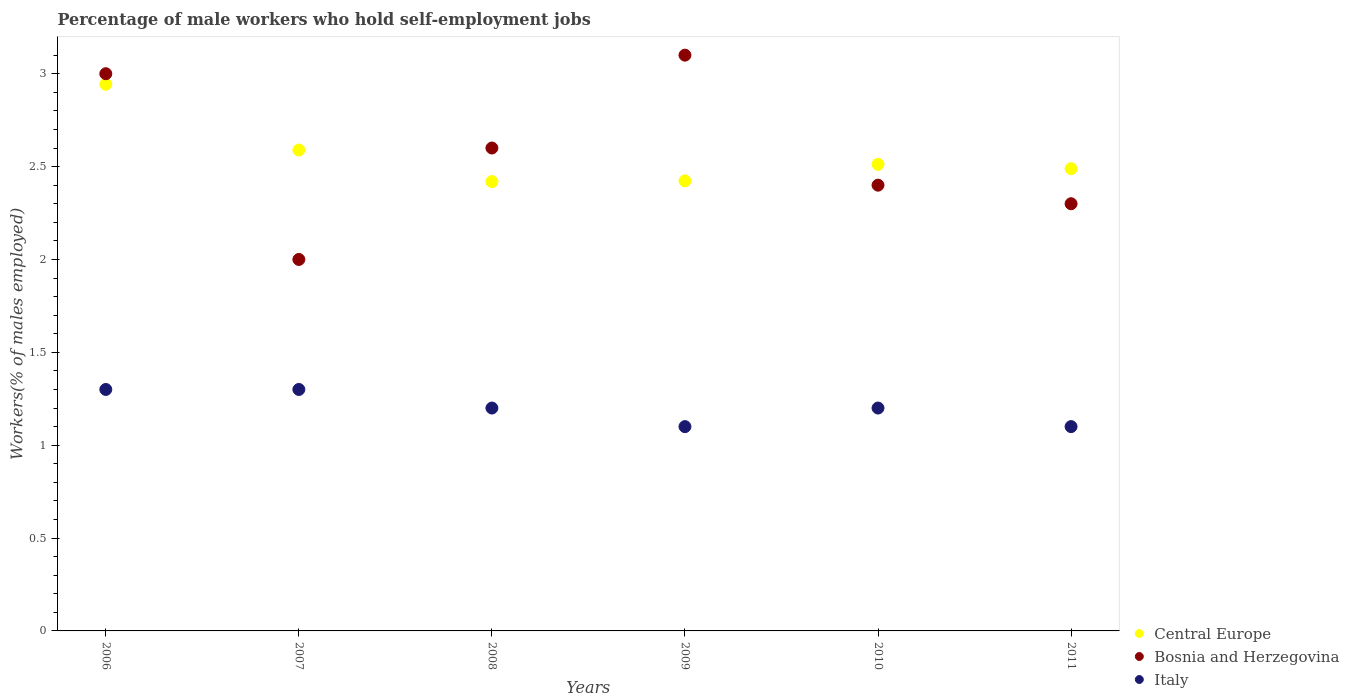How many different coloured dotlines are there?
Your response must be concise. 3. What is the percentage of self-employed male workers in Central Europe in 2007?
Keep it short and to the point. 2.59. Across all years, what is the maximum percentage of self-employed male workers in Central Europe?
Give a very brief answer. 2.94. Across all years, what is the minimum percentage of self-employed male workers in Bosnia and Herzegovina?
Make the answer very short. 2. What is the total percentage of self-employed male workers in Bosnia and Herzegovina in the graph?
Your answer should be compact. 15.4. What is the difference between the percentage of self-employed male workers in Bosnia and Herzegovina in 2007 and that in 2011?
Provide a short and direct response. -0.3. What is the difference between the percentage of self-employed male workers in Bosnia and Herzegovina in 2006 and the percentage of self-employed male workers in Central Europe in 2011?
Give a very brief answer. 0.51. What is the average percentage of self-employed male workers in Italy per year?
Keep it short and to the point. 1.2. In the year 2009, what is the difference between the percentage of self-employed male workers in Bosnia and Herzegovina and percentage of self-employed male workers in Italy?
Provide a short and direct response. 2. In how many years, is the percentage of self-employed male workers in Central Europe greater than 2.5 %?
Your answer should be compact. 3. What is the ratio of the percentage of self-employed male workers in Central Europe in 2007 to that in 2010?
Your answer should be very brief. 1.03. What is the difference between the highest and the lowest percentage of self-employed male workers in Central Europe?
Ensure brevity in your answer.  0.52. How many dotlines are there?
Your answer should be very brief. 3. How many years are there in the graph?
Your response must be concise. 6. What is the difference between two consecutive major ticks on the Y-axis?
Make the answer very short. 0.5. Where does the legend appear in the graph?
Provide a short and direct response. Bottom right. How many legend labels are there?
Offer a very short reply. 3. How are the legend labels stacked?
Your answer should be compact. Vertical. What is the title of the graph?
Ensure brevity in your answer.  Percentage of male workers who hold self-employment jobs. Does "Georgia" appear as one of the legend labels in the graph?
Your answer should be compact. No. What is the label or title of the Y-axis?
Provide a short and direct response. Workers(% of males employed). What is the Workers(% of males employed) of Central Europe in 2006?
Give a very brief answer. 2.94. What is the Workers(% of males employed) in Bosnia and Herzegovina in 2006?
Provide a succinct answer. 3. What is the Workers(% of males employed) of Italy in 2006?
Offer a very short reply. 1.3. What is the Workers(% of males employed) in Central Europe in 2007?
Provide a short and direct response. 2.59. What is the Workers(% of males employed) in Italy in 2007?
Your answer should be very brief. 1.3. What is the Workers(% of males employed) in Central Europe in 2008?
Your response must be concise. 2.42. What is the Workers(% of males employed) in Bosnia and Herzegovina in 2008?
Give a very brief answer. 2.6. What is the Workers(% of males employed) in Italy in 2008?
Make the answer very short. 1.2. What is the Workers(% of males employed) in Central Europe in 2009?
Your answer should be compact. 2.42. What is the Workers(% of males employed) of Bosnia and Herzegovina in 2009?
Offer a very short reply. 3.1. What is the Workers(% of males employed) in Italy in 2009?
Provide a succinct answer. 1.1. What is the Workers(% of males employed) of Central Europe in 2010?
Give a very brief answer. 2.51. What is the Workers(% of males employed) in Bosnia and Herzegovina in 2010?
Your response must be concise. 2.4. What is the Workers(% of males employed) of Italy in 2010?
Provide a succinct answer. 1.2. What is the Workers(% of males employed) in Central Europe in 2011?
Offer a terse response. 2.49. What is the Workers(% of males employed) in Bosnia and Herzegovina in 2011?
Keep it short and to the point. 2.3. What is the Workers(% of males employed) of Italy in 2011?
Offer a terse response. 1.1. Across all years, what is the maximum Workers(% of males employed) of Central Europe?
Make the answer very short. 2.94. Across all years, what is the maximum Workers(% of males employed) in Bosnia and Herzegovina?
Your answer should be very brief. 3.1. Across all years, what is the maximum Workers(% of males employed) of Italy?
Your answer should be very brief. 1.3. Across all years, what is the minimum Workers(% of males employed) in Central Europe?
Your response must be concise. 2.42. Across all years, what is the minimum Workers(% of males employed) in Bosnia and Herzegovina?
Ensure brevity in your answer.  2. Across all years, what is the minimum Workers(% of males employed) in Italy?
Give a very brief answer. 1.1. What is the total Workers(% of males employed) in Central Europe in the graph?
Offer a terse response. 15.38. What is the total Workers(% of males employed) of Italy in the graph?
Make the answer very short. 7.2. What is the difference between the Workers(% of males employed) of Central Europe in 2006 and that in 2007?
Make the answer very short. 0.35. What is the difference between the Workers(% of males employed) in Central Europe in 2006 and that in 2008?
Offer a very short reply. 0.52. What is the difference between the Workers(% of males employed) in Italy in 2006 and that in 2008?
Provide a succinct answer. 0.1. What is the difference between the Workers(% of males employed) in Central Europe in 2006 and that in 2009?
Your answer should be very brief. 0.52. What is the difference between the Workers(% of males employed) of Central Europe in 2006 and that in 2010?
Your answer should be compact. 0.43. What is the difference between the Workers(% of males employed) in Central Europe in 2006 and that in 2011?
Offer a very short reply. 0.45. What is the difference between the Workers(% of males employed) of Bosnia and Herzegovina in 2006 and that in 2011?
Offer a very short reply. 0.7. What is the difference between the Workers(% of males employed) of Central Europe in 2007 and that in 2008?
Provide a succinct answer. 0.17. What is the difference between the Workers(% of males employed) of Bosnia and Herzegovina in 2007 and that in 2008?
Provide a succinct answer. -0.6. What is the difference between the Workers(% of males employed) of Italy in 2007 and that in 2008?
Your answer should be very brief. 0.1. What is the difference between the Workers(% of males employed) of Central Europe in 2007 and that in 2009?
Your answer should be compact. 0.17. What is the difference between the Workers(% of males employed) of Bosnia and Herzegovina in 2007 and that in 2009?
Ensure brevity in your answer.  -1.1. What is the difference between the Workers(% of males employed) in Central Europe in 2007 and that in 2010?
Provide a short and direct response. 0.08. What is the difference between the Workers(% of males employed) in Central Europe in 2007 and that in 2011?
Your answer should be compact. 0.1. What is the difference between the Workers(% of males employed) of Bosnia and Herzegovina in 2007 and that in 2011?
Your answer should be compact. -0.3. What is the difference between the Workers(% of males employed) of Central Europe in 2008 and that in 2009?
Your answer should be very brief. -0. What is the difference between the Workers(% of males employed) of Italy in 2008 and that in 2009?
Ensure brevity in your answer.  0.1. What is the difference between the Workers(% of males employed) in Central Europe in 2008 and that in 2010?
Ensure brevity in your answer.  -0.09. What is the difference between the Workers(% of males employed) in Bosnia and Herzegovina in 2008 and that in 2010?
Offer a very short reply. 0.2. What is the difference between the Workers(% of males employed) in Central Europe in 2008 and that in 2011?
Your answer should be very brief. -0.07. What is the difference between the Workers(% of males employed) in Italy in 2008 and that in 2011?
Keep it short and to the point. 0.1. What is the difference between the Workers(% of males employed) in Central Europe in 2009 and that in 2010?
Make the answer very short. -0.09. What is the difference between the Workers(% of males employed) of Bosnia and Herzegovina in 2009 and that in 2010?
Offer a terse response. 0.7. What is the difference between the Workers(% of males employed) of Central Europe in 2009 and that in 2011?
Provide a succinct answer. -0.07. What is the difference between the Workers(% of males employed) in Bosnia and Herzegovina in 2009 and that in 2011?
Offer a terse response. 0.8. What is the difference between the Workers(% of males employed) in Italy in 2009 and that in 2011?
Make the answer very short. 0. What is the difference between the Workers(% of males employed) in Central Europe in 2010 and that in 2011?
Make the answer very short. 0.02. What is the difference between the Workers(% of males employed) in Central Europe in 2006 and the Workers(% of males employed) in Bosnia and Herzegovina in 2007?
Make the answer very short. 0.94. What is the difference between the Workers(% of males employed) of Central Europe in 2006 and the Workers(% of males employed) of Italy in 2007?
Ensure brevity in your answer.  1.64. What is the difference between the Workers(% of males employed) of Central Europe in 2006 and the Workers(% of males employed) of Bosnia and Herzegovina in 2008?
Ensure brevity in your answer.  0.34. What is the difference between the Workers(% of males employed) of Central Europe in 2006 and the Workers(% of males employed) of Italy in 2008?
Your answer should be very brief. 1.74. What is the difference between the Workers(% of males employed) in Bosnia and Herzegovina in 2006 and the Workers(% of males employed) in Italy in 2008?
Your answer should be very brief. 1.8. What is the difference between the Workers(% of males employed) in Central Europe in 2006 and the Workers(% of males employed) in Bosnia and Herzegovina in 2009?
Provide a short and direct response. -0.16. What is the difference between the Workers(% of males employed) in Central Europe in 2006 and the Workers(% of males employed) in Italy in 2009?
Keep it short and to the point. 1.84. What is the difference between the Workers(% of males employed) of Bosnia and Herzegovina in 2006 and the Workers(% of males employed) of Italy in 2009?
Keep it short and to the point. 1.9. What is the difference between the Workers(% of males employed) of Central Europe in 2006 and the Workers(% of males employed) of Bosnia and Herzegovina in 2010?
Make the answer very short. 0.54. What is the difference between the Workers(% of males employed) of Central Europe in 2006 and the Workers(% of males employed) of Italy in 2010?
Provide a short and direct response. 1.74. What is the difference between the Workers(% of males employed) of Central Europe in 2006 and the Workers(% of males employed) of Bosnia and Herzegovina in 2011?
Offer a very short reply. 0.64. What is the difference between the Workers(% of males employed) in Central Europe in 2006 and the Workers(% of males employed) in Italy in 2011?
Offer a very short reply. 1.84. What is the difference between the Workers(% of males employed) in Central Europe in 2007 and the Workers(% of males employed) in Bosnia and Herzegovina in 2008?
Your answer should be compact. -0.01. What is the difference between the Workers(% of males employed) in Central Europe in 2007 and the Workers(% of males employed) in Italy in 2008?
Ensure brevity in your answer.  1.39. What is the difference between the Workers(% of males employed) of Bosnia and Herzegovina in 2007 and the Workers(% of males employed) of Italy in 2008?
Offer a very short reply. 0.8. What is the difference between the Workers(% of males employed) of Central Europe in 2007 and the Workers(% of males employed) of Bosnia and Herzegovina in 2009?
Your answer should be very brief. -0.51. What is the difference between the Workers(% of males employed) of Central Europe in 2007 and the Workers(% of males employed) of Italy in 2009?
Make the answer very short. 1.49. What is the difference between the Workers(% of males employed) of Bosnia and Herzegovina in 2007 and the Workers(% of males employed) of Italy in 2009?
Provide a short and direct response. 0.9. What is the difference between the Workers(% of males employed) of Central Europe in 2007 and the Workers(% of males employed) of Bosnia and Herzegovina in 2010?
Keep it short and to the point. 0.19. What is the difference between the Workers(% of males employed) in Central Europe in 2007 and the Workers(% of males employed) in Italy in 2010?
Provide a short and direct response. 1.39. What is the difference between the Workers(% of males employed) in Bosnia and Herzegovina in 2007 and the Workers(% of males employed) in Italy in 2010?
Provide a succinct answer. 0.8. What is the difference between the Workers(% of males employed) of Central Europe in 2007 and the Workers(% of males employed) of Bosnia and Herzegovina in 2011?
Make the answer very short. 0.29. What is the difference between the Workers(% of males employed) in Central Europe in 2007 and the Workers(% of males employed) in Italy in 2011?
Make the answer very short. 1.49. What is the difference between the Workers(% of males employed) of Bosnia and Herzegovina in 2007 and the Workers(% of males employed) of Italy in 2011?
Give a very brief answer. 0.9. What is the difference between the Workers(% of males employed) of Central Europe in 2008 and the Workers(% of males employed) of Bosnia and Herzegovina in 2009?
Give a very brief answer. -0.68. What is the difference between the Workers(% of males employed) of Central Europe in 2008 and the Workers(% of males employed) of Italy in 2009?
Offer a very short reply. 1.32. What is the difference between the Workers(% of males employed) of Bosnia and Herzegovina in 2008 and the Workers(% of males employed) of Italy in 2009?
Your answer should be compact. 1.5. What is the difference between the Workers(% of males employed) in Central Europe in 2008 and the Workers(% of males employed) in Bosnia and Herzegovina in 2010?
Ensure brevity in your answer.  0.02. What is the difference between the Workers(% of males employed) in Central Europe in 2008 and the Workers(% of males employed) in Italy in 2010?
Keep it short and to the point. 1.22. What is the difference between the Workers(% of males employed) in Bosnia and Herzegovina in 2008 and the Workers(% of males employed) in Italy in 2010?
Offer a very short reply. 1.4. What is the difference between the Workers(% of males employed) of Central Europe in 2008 and the Workers(% of males employed) of Bosnia and Herzegovina in 2011?
Your answer should be very brief. 0.12. What is the difference between the Workers(% of males employed) of Central Europe in 2008 and the Workers(% of males employed) of Italy in 2011?
Your answer should be very brief. 1.32. What is the difference between the Workers(% of males employed) in Central Europe in 2009 and the Workers(% of males employed) in Bosnia and Herzegovina in 2010?
Give a very brief answer. 0.02. What is the difference between the Workers(% of males employed) in Central Europe in 2009 and the Workers(% of males employed) in Italy in 2010?
Your response must be concise. 1.22. What is the difference between the Workers(% of males employed) of Bosnia and Herzegovina in 2009 and the Workers(% of males employed) of Italy in 2010?
Your response must be concise. 1.9. What is the difference between the Workers(% of males employed) in Central Europe in 2009 and the Workers(% of males employed) in Bosnia and Herzegovina in 2011?
Make the answer very short. 0.12. What is the difference between the Workers(% of males employed) in Central Europe in 2009 and the Workers(% of males employed) in Italy in 2011?
Your answer should be very brief. 1.32. What is the difference between the Workers(% of males employed) in Bosnia and Herzegovina in 2009 and the Workers(% of males employed) in Italy in 2011?
Offer a terse response. 2. What is the difference between the Workers(% of males employed) of Central Europe in 2010 and the Workers(% of males employed) of Bosnia and Herzegovina in 2011?
Offer a very short reply. 0.21. What is the difference between the Workers(% of males employed) of Central Europe in 2010 and the Workers(% of males employed) of Italy in 2011?
Give a very brief answer. 1.41. What is the difference between the Workers(% of males employed) in Bosnia and Herzegovina in 2010 and the Workers(% of males employed) in Italy in 2011?
Provide a short and direct response. 1.3. What is the average Workers(% of males employed) of Central Europe per year?
Make the answer very short. 2.56. What is the average Workers(% of males employed) of Bosnia and Herzegovina per year?
Provide a short and direct response. 2.57. In the year 2006, what is the difference between the Workers(% of males employed) in Central Europe and Workers(% of males employed) in Bosnia and Herzegovina?
Your response must be concise. -0.06. In the year 2006, what is the difference between the Workers(% of males employed) of Central Europe and Workers(% of males employed) of Italy?
Offer a terse response. 1.64. In the year 2006, what is the difference between the Workers(% of males employed) in Bosnia and Herzegovina and Workers(% of males employed) in Italy?
Keep it short and to the point. 1.7. In the year 2007, what is the difference between the Workers(% of males employed) of Central Europe and Workers(% of males employed) of Bosnia and Herzegovina?
Your response must be concise. 0.59. In the year 2007, what is the difference between the Workers(% of males employed) in Central Europe and Workers(% of males employed) in Italy?
Offer a very short reply. 1.29. In the year 2007, what is the difference between the Workers(% of males employed) in Bosnia and Herzegovina and Workers(% of males employed) in Italy?
Give a very brief answer. 0.7. In the year 2008, what is the difference between the Workers(% of males employed) in Central Europe and Workers(% of males employed) in Bosnia and Herzegovina?
Give a very brief answer. -0.18. In the year 2008, what is the difference between the Workers(% of males employed) in Central Europe and Workers(% of males employed) in Italy?
Provide a succinct answer. 1.22. In the year 2009, what is the difference between the Workers(% of males employed) in Central Europe and Workers(% of males employed) in Bosnia and Herzegovina?
Offer a terse response. -0.68. In the year 2009, what is the difference between the Workers(% of males employed) of Central Europe and Workers(% of males employed) of Italy?
Offer a very short reply. 1.32. In the year 2010, what is the difference between the Workers(% of males employed) of Central Europe and Workers(% of males employed) of Bosnia and Herzegovina?
Offer a terse response. 0.11. In the year 2010, what is the difference between the Workers(% of males employed) in Central Europe and Workers(% of males employed) in Italy?
Your answer should be compact. 1.31. In the year 2010, what is the difference between the Workers(% of males employed) of Bosnia and Herzegovina and Workers(% of males employed) of Italy?
Offer a very short reply. 1.2. In the year 2011, what is the difference between the Workers(% of males employed) of Central Europe and Workers(% of males employed) of Bosnia and Herzegovina?
Make the answer very short. 0.19. In the year 2011, what is the difference between the Workers(% of males employed) in Central Europe and Workers(% of males employed) in Italy?
Provide a succinct answer. 1.39. In the year 2011, what is the difference between the Workers(% of males employed) of Bosnia and Herzegovina and Workers(% of males employed) of Italy?
Offer a terse response. 1.2. What is the ratio of the Workers(% of males employed) of Central Europe in 2006 to that in 2007?
Keep it short and to the point. 1.14. What is the ratio of the Workers(% of males employed) in Bosnia and Herzegovina in 2006 to that in 2007?
Make the answer very short. 1.5. What is the ratio of the Workers(% of males employed) in Italy in 2006 to that in 2007?
Provide a short and direct response. 1. What is the ratio of the Workers(% of males employed) of Central Europe in 2006 to that in 2008?
Your answer should be compact. 1.22. What is the ratio of the Workers(% of males employed) in Bosnia and Herzegovina in 2006 to that in 2008?
Your answer should be very brief. 1.15. What is the ratio of the Workers(% of males employed) in Central Europe in 2006 to that in 2009?
Offer a very short reply. 1.21. What is the ratio of the Workers(% of males employed) in Italy in 2006 to that in 2009?
Offer a terse response. 1.18. What is the ratio of the Workers(% of males employed) in Central Europe in 2006 to that in 2010?
Your answer should be very brief. 1.17. What is the ratio of the Workers(% of males employed) of Bosnia and Herzegovina in 2006 to that in 2010?
Your response must be concise. 1.25. What is the ratio of the Workers(% of males employed) in Central Europe in 2006 to that in 2011?
Give a very brief answer. 1.18. What is the ratio of the Workers(% of males employed) in Bosnia and Herzegovina in 2006 to that in 2011?
Your answer should be compact. 1.3. What is the ratio of the Workers(% of males employed) in Italy in 2006 to that in 2011?
Ensure brevity in your answer.  1.18. What is the ratio of the Workers(% of males employed) of Central Europe in 2007 to that in 2008?
Your answer should be compact. 1.07. What is the ratio of the Workers(% of males employed) in Bosnia and Herzegovina in 2007 to that in 2008?
Make the answer very short. 0.77. What is the ratio of the Workers(% of males employed) of Italy in 2007 to that in 2008?
Provide a short and direct response. 1.08. What is the ratio of the Workers(% of males employed) of Central Europe in 2007 to that in 2009?
Your response must be concise. 1.07. What is the ratio of the Workers(% of males employed) in Bosnia and Herzegovina in 2007 to that in 2009?
Offer a very short reply. 0.65. What is the ratio of the Workers(% of males employed) in Italy in 2007 to that in 2009?
Keep it short and to the point. 1.18. What is the ratio of the Workers(% of males employed) in Central Europe in 2007 to that in 2010?
Offer a very short reply. 1.03. What is the ratio of the Workers(% of males employed) of Bosnia and Herzegovina in 2007 to that in 2010?
Offer a terse response. 0.83. What is the ratio of the Workers(% of males employed) in Italy in 2007 to that in 2010?
Ensure brevity in your answer.  1.08. What is the ratio of the Workers(% of males employed) of Central Europe in 2007 to that in 2011?
Your answer should be very brief. 1.04. What is the ratio of the Workers(% of males employed) in Bosnia and Herzegovina in 2007 to that in 2011?
Your answer should be compact. 0.87. What is the ratio of the Workers(% of males employed) in Italy in 2007 to that in 2011?
Make the answer very short. 1.18. What is the ratio of the Workers(% of males employed) of Central Europe in 2008 to that in 2009?
Keep it short and to the point. 1. What is the ratio of the Workers(% of males employed) in Bosnia and Herzegovina in 2008 to that in 2009?
Offer a very short reply. 0.84. What is the ratio of the Workers(% of males employed) of Italy in 2008 to that in 2009?
Provide a succinct answer. 1.09. What is the ratio of the Workers(% of males employed) of Central Europe in 2008 to that in 2010?
Offer a terse response. 0.96. What is the ratio of the Workers(% of males employed) of Bosnia and Herzegovina in 2008 to that in 2010?
Provide a succinct answer. 1.08. What is the ratio of the Workers(% of males employed) in Italy in 2008 to that in 2010?
Make the answer very short. 1. What is the ratio of the Workers(% of males employed) in Central Europe in 2008 to that in 2011?
Make the answer very short. 0.97. What is the ratio of the Workers(% of males employed) in Bosnia and Herzegovina in 2008 to that in 2011?
Your answer should be very brief. 1.13. What is the ratio of the Workers(% of males employed) of Central Europe in 2009 to that in 2010?
Keep it short and to the point. 0.96. What is the ratio of the Workers(% of males employed) of Bosnia and Herzegovina in 2009 to that in 2010?
Give a very brief answer. 1.29. What is the ratio of the Workers(% of males employed) in Italy in 2009 to that in 2010?
Your response must be concise. 0.92. What is the ratio of the Workers(% of males employed) in Central Europe in 2009 to that in 2011?
Ensure brevity in your answer.  0.97. What is the ratio of the Workers(% of males employed) of Bosnia and Herzegovina in 2009 to that in 2011?
Your answer should be compact. 1.35. What is the ratio of the Workers(% of males employed) of Central Europe in 2010 to that in 2011?
Offer a very short reply. 1.01. What is the ratio of the Workers(% of males employed) in Bosnia and Herzegovina in 2010 to that in 2011?
Provide a succinct answer. 1.04. What is the difference between the highest and the second highest Workers(% of males employed) in Central Europe?
Your answer should be compact. 0.35. What is the difference between the highest and the second highest Workers(% of males employed) in Italy?
Provide a succinct answer. 0. What is the difference between the highest and the lowest Workers(% of males employed) in Central Europe?
Provide a succinct answer. 0.52. What is the difference between the highest and the lowest Workers(% of males employed) in Bosnia and Herzegovina?
Provide a short and direct response. 1.1. What is the difference between the highest and the lowest Workers(% of males employed) of Italy?
Your response must be concise. 0.2. 